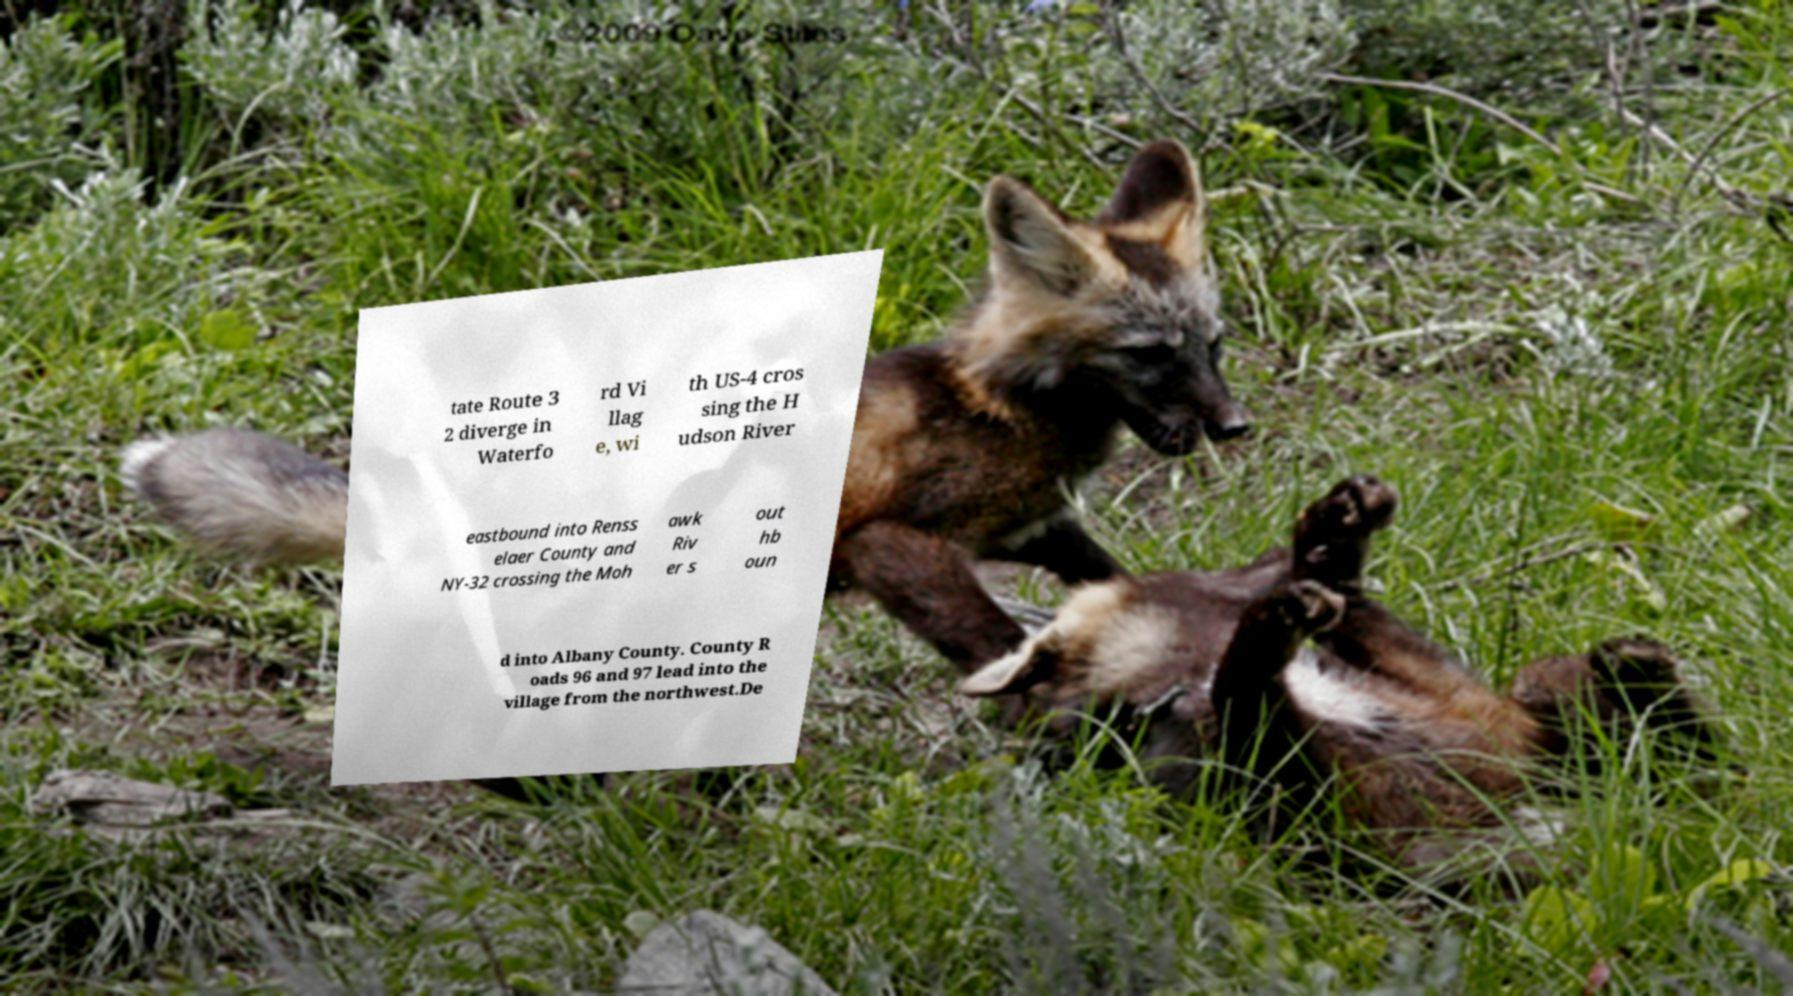There's text embedded in this image that I need extracted. Can you transcribe it verbatim? tate Route 3 2 diverge in Waterfo rd Vi llag e, wi th US-4 cros sing the H udson River eastbound into Renss elaer County and NY-32 crossing the Moh awk Riv er s out hb oun d into Albany County. County R oads 96 and 97 lead into the village from the northwest.De 